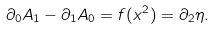<formula> <loc_0><loc_0><loc_500><loc_500>\partial _ { 0 } A _ { 1 } - \partial _ { 1 } A _ { 0 } = f ( x ^ { 2 } ) = \partial _ { 2 } \eta .</formula> 